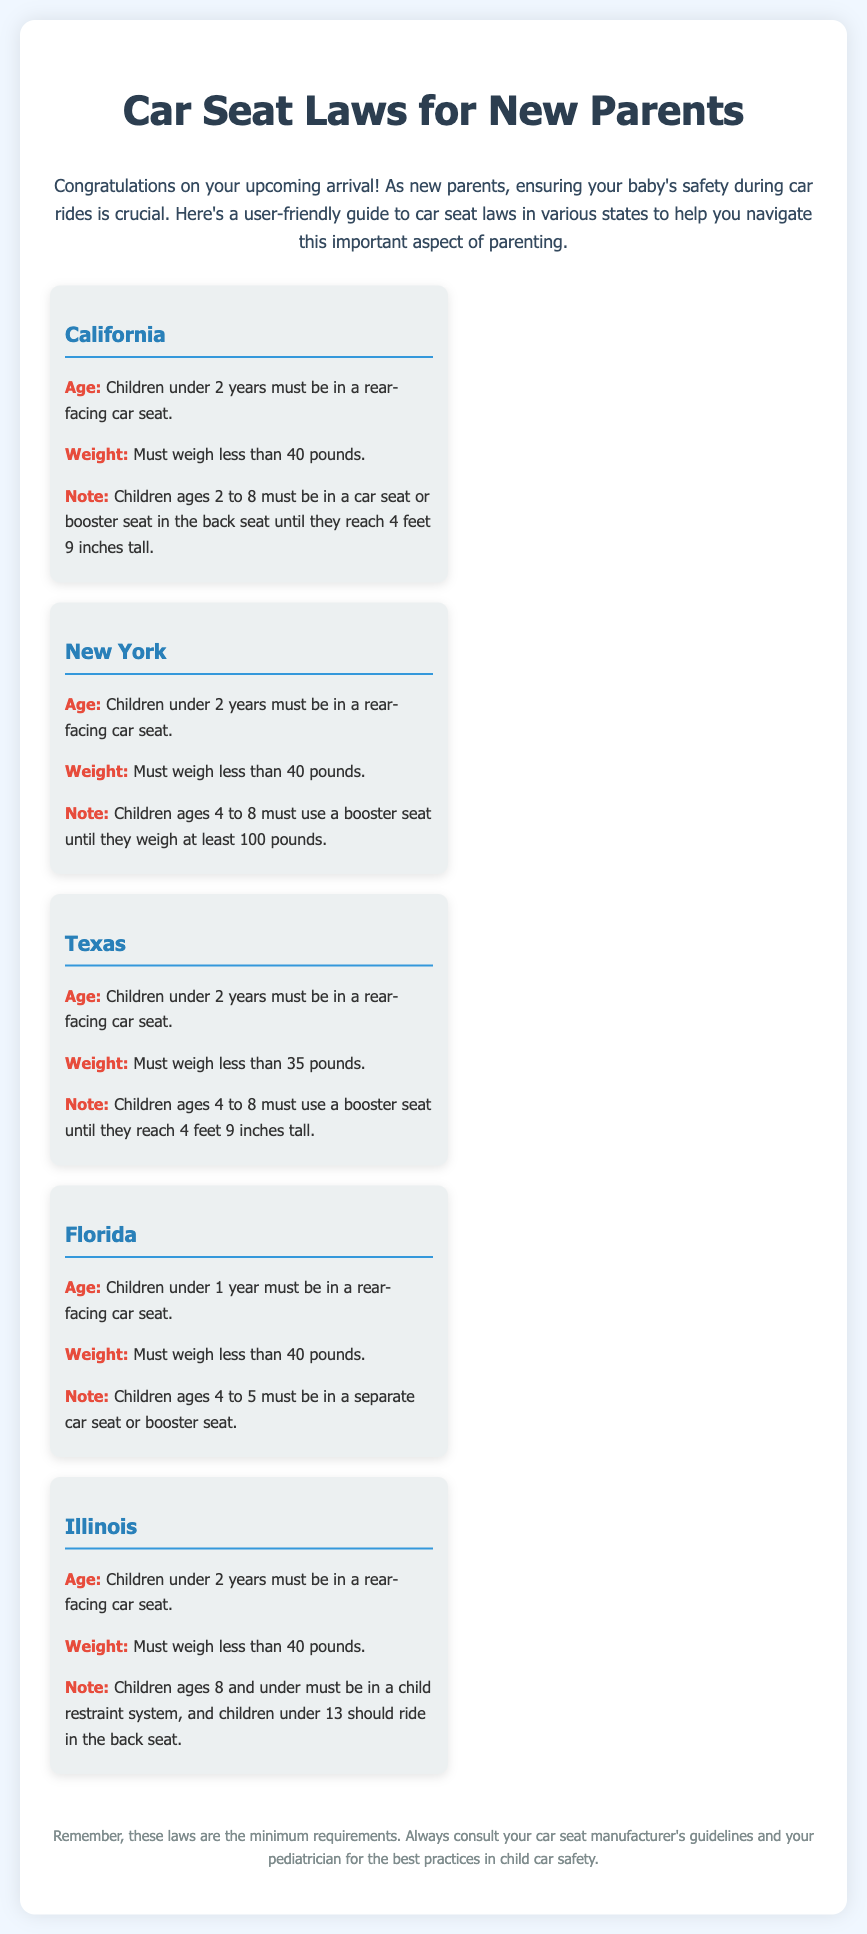what is the age requirement for rear-facing car seats in California? In California, children under 2 years must be in a rear-facing car seat.
Answer: under 2 years what is the weight limit for rear-facing car seats in New York? In New York, children must weigh less than 40 pounds to be in a rear-facing car seat.
Answer: less than 40 pounds what is the booster seat requirement for children 4 to 8 in Texas? In Texas, children ages 4 to 8 must use a booster seat until they reach 4 feet 9 inches tall.
Answer: until they reach 4 feet 9 inches tall what is the age requirement for rear-facing car seats in Florida? In Florida, children under 1 year must be in a rear-facing car seat.
Answer: under 1 year how many years must children be in a child restraint system in Illinois? In Illinois, children ages 8 and under must be in a child restraint system.
Answer: ages 8 and under what is the specific weight limit for a rear-facing car seat in Texas? In Texas, the weight limit for a rear-facing car seat is less than 35 pounds.
Answer: less than 35 pounds which state requires a child seat for children ages 4 to 5? Florida requires a separate car seat or booster seat for children ages 4 to 5.
Answer: Florida at what age do children no longer need to be in a booster seat in New York? In New York, children must use a booster seat until they weigh at least 100 pounds.
Answer: at least 100 pounds which state mandates back seat riding for children under 13? Illinois mandates that children under 13 should ride in the back seat.
Answer: Illinois 